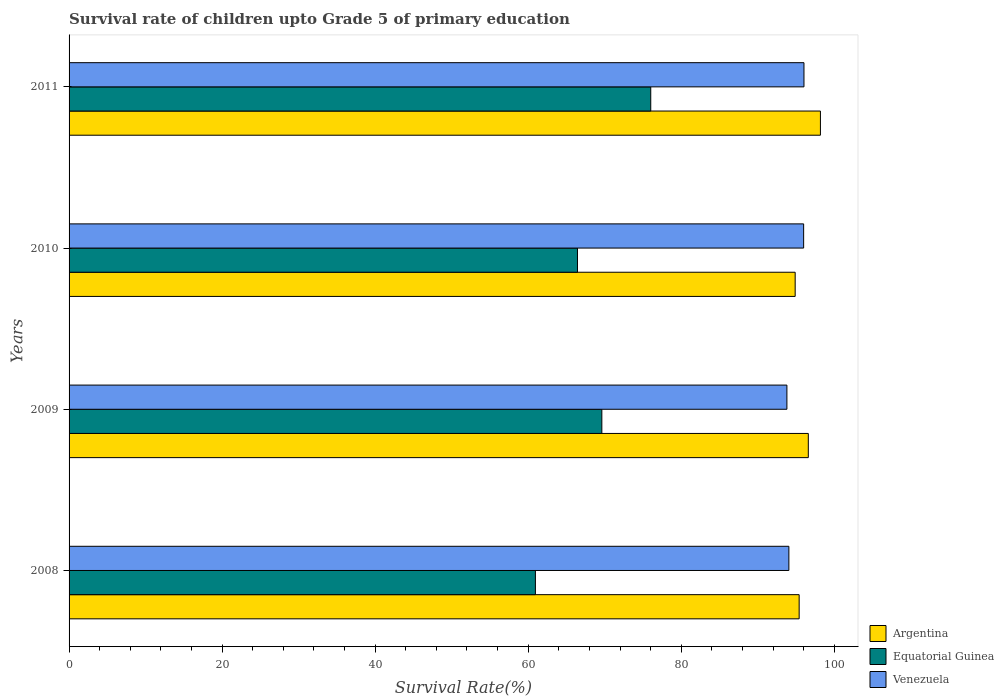Are the number of bars per tick equal to the number of legend labels?
Keep it short and to the point. Yes. Are the number of bars on each tick of the Y-axis equal?
Your answer should be very brief. Yes. How many bars are there on the 1st tick from the bottom?
Ensure brevity in your answer.  3. In how many cases, is the number of bars for a given year not equal to the number of legend labels?
Give a very brief answer. 0. What is the survival rate of children in Argentina in 2011?
Keep it short and to the point. 98.19. Across all years, what is the maximum survival rate of children in Argentina?
Your answer should be very brief. 98.19. Across all years, what is the minimum survival rate of children in Venezuela?
Your response must be concise. 93.81. In which year was the survival rate of children in Venezuela minimum?
Your response must be concise. 2009. What is the total survival rate of children in Argentina in the graph?
Give a very brief answer. 385.11. What is the difference between the survival rate of children in Argentina in 2009 and that in 2011?
Your response must be concise. -1.58. What is the difference between the survival rate of children in Venezuela in 2010 and the survival rate of children in Equatorial Guinea in 2009?
Offer a terse response. 26.37. What is the average survival rate of children in Argentina per year?
Give a very brief answer. 96.28. In the year 2010, what is the difference between the survival rate of children in Equatorial Guinea and survival rate of children in Venezuela?
Keep it short and to the point. -29.56. What is the ratio of the survival rate of children in Equatorial Guinea in 2008 to that in 2010?
Your answer should be compact. 0.92. Is the difference between the survival rate of children in Equatorial Guinea in 2008 and 2010 greater than the difference between the survival rate of children in Venezuela in 2008 and 2010?
Keep it short and to the point. No. What is the difference between the highest and the second highest survival rate of children in Argentina?
Offer a terse response. 1.58. What is the difference between the highest and the lowest survival rate of children in Equatorial Guinea?
Ensure brevity in your answer.  15.07. Is the sum of the survival rate of children in Venezuela in 2008 and 2010 greater than the maximum survival rate of children in Equatorial Guinea across all years?
Provide a succinct answer. Yes. What does the 3rd bar from the top in 2008 represents?
Ensure brevity in your answer.  Argentina. What is the difference between two consecutive major ticks on the X-axis?
Make the answer very short. 20. Are the values on the major ticks of X-axis written in scientific E-notation?
Make the answer very short. No. How many legend labels are there?
Your response must be concise. 3. How are the legend labels stacked?
Offer a very short reply. Vertical. What is the title of the graph?
Make the answer very short. Survival rate of children upto Grade 5 of primary education. Does "Dominica" appear as one of the legend labels in the graph?
Your answer should be compact. No. What is the label or title of the X-axis?
Your answer should be compact. Survival Rate(%). What is the label or title of the Y-axis?
Offer a very short reply. Years. What is the Survival Rate(%) of Argentina in 2008?
Provide a succinct answer. 95.41. What is the Survival Rate(%) of Equatorial Guinea in 2008?
Keep it short and to the point. 60.94. What is the Survival Rate(%) of Venezuela in 2008?
Provide a short and direct response. 94.07. What is the Survival Rate(%) in Argentina in 2009?
Give a very brief answer. 96.61. What is the Survival Rate(%) in Equatorial Guinea in 2009?
Give a very brief answer. 69.63. What is the Survival Rate(%) of Venezuela in 2009?
Make the answer very short. 93.81. What is the Survival Rate(%) of Argentina in 2010?
Ensure brevity in your answer.  94.89. What is the Survival Rate(%) in Equatorial Guinea in 2010?
Offer a terse response. 66.44. What is the Survival Rate(%) in Venezuela in 2010?
Provide a succinct answer. 96. What is the Survival Rate(%) in Argentina in 2011?
Provide a succinct answer. 98.19. What is the Survival Rate(%) of Equatorial Guinea in 2011?
Ensure brevity in your answer.  76.02. What is the Survival Rate(%) of Venezuela in 2011?
Provide a succinct answer. 96.04. Across all years, what is the maximum Survival Rate(%) of Argentina?
Provide a short and direct response. 98.19. Across all years, what is the maximum Survival Rate(%) of Equatorial Guinea?
Keep it short and to the point. 76.02. Across all years, what is the maximum Survival Rate(%) of Venezuela?
Offer a very short reply. 96.04. Across all years, what is the minimum Survival Rate(%) in Argentina?
Provide a succinct answer. 94.89. Across all years, what is the minimum Survival Rate(%) of Equatorial Guinea?
Ensure brevity in your answer.  60.94. Across all years, what is the minimum Survival Rate(%) of Venezuela?
Keep it short and to the point. 93.81. What is the total Survival Rate(%) in Argentina in the graph?
Provide a short and direct response. 385.11. What is the total Survival Rate(%) in Equatorial Guinea in the graph?
Ensure brevity in your answer.  273.03. What is the total Survival Rate(%) in Venezuela in the graph?
Your response must be concise. 379.92. What is the difference between the Survival Rate(%) of Argentina in 2008 and that in 2009?
Provide a short and direct response. -1.2. What is the difference between the Survival Rate(%) of Equatorial Guinea in 2008 and that in 2009?
Keep it short and to the point. -8.68. What is the difference between the Survival Rate(%) of Venezuela in 2008 and that in 2009?
Provide a succinct answer. 0.26. What is the difference between the Survival Rate(%) in Argentina in 2008 and that in 2010?
Offer a terse response. 0.52. What is the difference between the Survival Rate(%) of Equatorial Guinea in 2008 and that in 2010?
Offer a very short reply. -5.5. What is the difference between the Survival Rate(%) in Venezuela in 2008 and that in 2010?
Your answer should be very brief. -1.93. What is the difference between the Survival Rate(%) in Argentina in 2008 and that in 2011?
Your response must be concise. -2.78. What is the difference between the Survival Rate(%) in Equatorial Guinea in 2008 and that in 2011?
Your answer should be very brief. -15.07. What is the difference between the Survival Rate(%) of Venezuela in 2008 and that in 2011?
Offer a terse response. -1.97. What is the difference between the Survival Rate(%) of Argentina in 2009 and that in 2010?
Your response must be concise. 1.72. What is the difference between the Survival Rate(%) of Equatorial Guinea in 2009 and that in 2010?
Make the answer very short. 3.18. What is the difference between the Survival Rate(%) of Venezuela in 2009 and that in 2010?
Make the answer very short. -2.19. What is the difference between the Survival Rate(%) in Argentina in 2009 and that in 2011?
Offer a terse response. -1.58. What is the difference between the Survival Rate(%) in Equatorial Guinea in 2009 and that in 2011?
Your answer should be very brief. -6.39. What is the difference between the Survival Rate(%) in Venezuela in 2009 and that in 2011?
Your answer should be very brief. -2.23. What is the difference between the Survival Rate(%) in Argentina in 2010 and that in 2011?
Your answer should be very brief. -3.3. What is the difference between the Survival Rate(%) in Equatorial Guinea in 2010 and that in 2011?
Keep it short and to the point. -9.58. What is the difference between the Survival Rate(%) in Venezuela in 2010 and that in 2011?
Keep it short and to the point. -0.04. What is the difference between the Survival Rate(%) of Argentina in 2008 and the Survival Rate(%) of Equatorial Guinea in 2009?
Offer a terse response. 25.79. What is the difference between the Survival Rate(%) in Argentina in 2008 and the Survival Rate(%) in Venezuela in 2009?
Your answer should be compact. 1.6. What is the difference between the Survival Rate(%) in Equatorial Guinea in 2008 and the Survival Rate(%) in Venezuela in 2009?
Your answer should be very brief. -32.87. What is the difference between the Survival Rate(%) of Argentina in 2008 and the Survival Rate(%) of Equatorial Guinea in 2010?
Your answer should be compact. 28.97. What is the difference between the Survival Rate(%) in Argentina in 2008 and the Survival Rate(%) in Venezuela in 2010?
Make the answer very short. -0.59. What is the difference between the Survival Rate(%) in Equatorial Guinea in 2008 and the Survival Rate(%) in Venezuela in 2010?
Your response must be concise. -35.05. What is the difference between the Survival Rate(%) in Argentina in 2008 and the Survival Rate(%) in Equatorial Guinea in 2011?
Your response must be concise. 19.4. What is the difference between the Survival Rate(%) in Argentina in 2008 and the Survival Rate(%) in Venezuela in 2011?
Offer a terse response. -0.63. What is the difference between the Survival Rate(%) in Equatorial Guinea in 2008 and the Survival Rate(%) in Venezuela in 2011?
Ensure brevity in your answer.  -35.1. What is the difference between the Survival Rate(%) in Argentina in 2009 and the Survival Rate(%) in Equatorial Guinea in 2010?
Your answer should be very brief. 30.17. What is the difference between the Survival Rate(%) in Argentina in 2009 and the Survival Rate(%) in Venezuela in 2010?
Offer a very short reply. 0.61. What is the difference between the Survival Rate(%) of Equatorial Guinea in 2009 and the Survival Rate(%) of Venezuela in 2010?
Your response must be concise. -26.37. What is the difference between the Survival Rate(%) of Argentina in 2009 and the Survival Rate(%) of Equatorial Guinea in 2011?
Provide a short and direct response. 20.59. What is the difference between the Survival Rate(%) of Argentina in 2009 and the Survival Rate(%) of Venezuela in 2011?
Your answer should be compact. 0.57. What is the difference between the Survival Rate(%) of Equatorial Guinea in 2009 and the Survival Rate(%) of Venezuela in 2011?
Offer a very short reply. -26.41. What is the difference between the Survival Rate(%) in Argentina in 2010 and the Survival Rate(%) in Equatorial Guinea in 2011?
Offer a very short reply. 18.88. What is the difference between the Survival Rate(%) in Argentina in 2010 and the Survival Rate(%) in Venezuela in 2011?
Your answer should be very brief. -1.15. What is the difference between the Survival Rate(%) in Equatorial Guinea in 2010 and the Survival Rate(%) in Venezuela in 2011?
Offer a terse response. -29.6. What is the average Survival Rate(%) of Argentina per year?
Offer a terse response. 96.28. What is the average Survival Rate(%) in Equatorial Guinea per year?
Give a very brief answer. 68.26. What is the average Survival Rate(%) in Venezuela per year?
Offer a terse response. 94.98. In the year 2008, what is the difference between the Survival Rate(%) in Argentina and Survival Rate(%) in Equatorial Guinea?
Offer a terse response. 34.47. In the year 2008, what is the difference between the Survival Rate(%) of Argentina and Survival Rate(%) of Venezuela?
Offer a very short reply. 1.34. In the year 2008, what is the difference between the Survival Rate(%) in Equatorial Guinea and Survival Rate(%) in Venezuela?
Give a very brief answer. -33.12. In the year 2009, what is the difference between the Survival Rate(%) in Argentina and Survival Rate(%) in Equatorial Guinea?
Ensure brevity in your answer.  26.98. In the year 2009, what is the difference between the Survival Rate(%) of Argentina and Survival Rate(%) of Venezuela?
Provide a succinct answer. 2.8. In the year 2009, what is the difference between the Survival Rate(%) of Equatorial Guinea and Survival Rate(%) of Venezuela?
Provide a succinct answer. -24.18. In the year 2010, what is the difference between the Survival Rate(%) in Argentina and Survival Rate(%) in Equatorial Guinea?
Make the answer very short. 28.45. In the year 2010, what is the difference between the Survival Rate(%) in Argentina and Survival Rate(%) in Venezuela?
Ensure brevity in your answer.  -1.11. In the year 2010, what is the difference between the Survival Rate(%) of Equatorial Guinea and Survival Rate(%) of Venezuela?
Keep it short and to the point. -29.56. In the year 2011, what is the difference between the Survival Rate(%) in Argentina and Survival Rate(%) in Equatorial Guinea?
Your answer should be compact. 22.17. In the year 2011, what is the difference between the Survival Rate(%) in Argentina and Survival Rate(%) in Venezuela?
Give a very brief answer. 2.15. In the year 2011, what is the difference between the Survival Rate(%) in Equatorial Guinea and Survival Rate(%) in Venezuela?
Provide a succinct answer. -20.02. What is the ratio of the Survival Rate(%) in Argentina in 2008 to that in 2009?
Your response must be concise. 0.99. What is the ratio of the Survival Rate(%) of Equatorial Guinea in 2008 to that in 2009?
Ensure brevity in your answer.  0.88. What is the ratio of the Survival Rate(%) of Venezuela in 2008 to that in 2009?
Provide a short and direct response. 1. What is the ratio of the Survival Rate(%) in Equatorial Guinea in 2008 to that in 2010?
Ensure brevity in your answer.  0.92. What is the ratio of the Survival Rate(%) in Venezuela in 2008 to that in 2010?
Provide a short and direct response. 0.98. What is the ratio of the Survival Rate(%) in Argentina in 2008 to that in 2011?
Your answer should be compact. 0.97. What is the ratio of the Survival Rate(%) in Equatorial Guinea in 2008 to that in 2011?
Provide a short and direct response. 0.8. What is the ratio of the Survival Rate(%) of Venezuela in 2008 to that in 2011?
Make the answer very short. 0.98. What is the ratio of the Survival Rate(%) of Argentina in 2009 to that in 2010?
Your response must be concise. 1.02. What is the ratio of the Survival Rate(%) of Equatorial Guinea in 2009 to that in 2010?
Give a very brief answer. 1.05. What is the ratio of the Survival Rate(%) in Venezuela in 2009 to that in 2010?
Offer a terse response. 0.98. What is the ratio of the Survival Rate(%) of Argentina in 2009 to that in 2011?
Make the answer very short. 0.98. What is the ratio of the Survival Rate(%) in Equatorial Guinea in 2009 to that in 2011?
Offer a very short reply. 0.92. What is the ratio of the Survival Rate(%) in Venezuela in 2009 to that in 2011?
Offer a terse response. 0.98. What is the ratio of the Survival Rate(%) of Argentina in 2010 to that in 2011?
Offer a very short reply. 0.97. What is the ratio of the Survival Rate(%) of Equatorial Guinea in 2010 to that in 2011?
Ensure brevity in your answer.  0.87. What is the difference between the highest and the second highest Survival Rate(%) in Argentina?
Ensure brevity in your answer.  1.58. What is the difference between the highest and the second highest Survival Rate(%) in Equatorial Guinea?
Provide a short and direct response. 6.39. What is the difference between the highest and the second highest Survival Rate(%) of Venezuela?
Provide a succinct answer. 0.04. What is the difference between the highest and the lowest Survival Rate(%) in Argentina?
Give a very brief answer. 3.3. What is the difference between the highest and the lowest Survival Rate(%) in Equatorial Guinea?
Give a very brief answer. 15.07. What is the difference between the highest and the lowest Survival Rate(%) in Venezuela?
Provide a short and direct response. 2.23. 